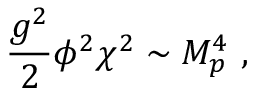Convert formula to latex. <formula><loc_0><loc_0><loc_500><loc_500>{ \frac { g ^ { 2 } } { 2 } } \phi ^ { 2 } \chi ^ { 2 } \sim M _ { p } ^ { 4 } \ ,</formula> 